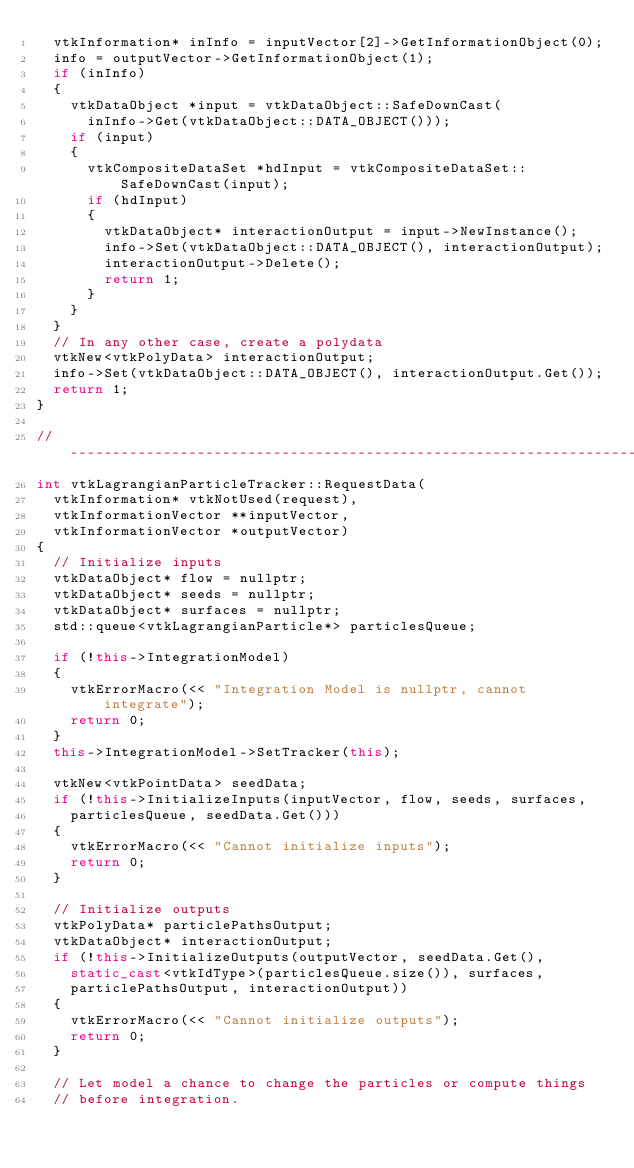Convert code to text. <code><loc_0><loc_0><loc_500><loc_500><_C++_>  vtkInformation* inInfo = inputVector[2]->GetInformationObject(0);
  info = outputVector->GetInformationObject(1);
  if (inInfo)
  {
    vtkDataObject *input = vtkDataObject::SafeDownCast(
      inInfo->Get(vtkDataObject::DATA_OBJECT()));
    if (input)
    {
      vtkCompositeDataSet *hdInput = vtkCompositeDataSet::SafeDownCast(input);
      if (hdInput)
      {
        vtkDataObject* interactionOutput = input->NewInstance();
        info->Set(vtkDataObject::DATA_OBJECT(), interactionOutput);
        interactionOutput->Delete();
        return 1;
      }
    }
  }
  // In any other case, create a polydata
  vtkNew<vtkPolyData> interactionOutput;
  info->Set(vtkDataObject::DATA_OBJECT(), interactionOutput.Get());
  return 1;
}

//---------------------------------------------------------------------------
int vtkLagrangianParticleTracker::RequestData(
  vtkInformation* vtkNotUsed(request),
  vtkInformationVector **inputVector,
  vtkInformationVector *outputVector)
{
  // Initialize inputs
  vtkDataObject* flow = nullptr;
  vtkDataObject* seeds = nullptr;
  vtkDataObject* surfaces = nullptr;
  std::queue<vtkLagrangianParticle*> particlesQueue;

  if (!this->IntegrationModel)
  {
    vtkErrorMacro(<< "Integration Model is nullptr, cannot integrate");
    return 0;
  }
  this->IntegrationModel->SetTracker(this);

  vtkNew<vtkPointData> seedData;
  if (!this->InitializeInputs(inputVector, flow, seeds, surfaces,
    particlesQueue, seedData.Get()))
  {
    vtkErrorMacro(<< "Cannot initialize inputs");
    return 0;
  }

  // Initialize outputs
  vtkPolyData* particlePathsOutput;
  vtkDataObject* interactionOutput;
  if (!this->InitializeOutputs(outputVector, seedData.Get(),
    static_cast<vtkIdType>(particlesQueue.size()), surfaces,
    particlePathsOutput, interactionOutput))
  {
    vtkErrorMacro(<< "Cannot initialize outputs");
    return 0;
  }

  // Let model a chance to change the particles or compute things
  // before integration.</code> 